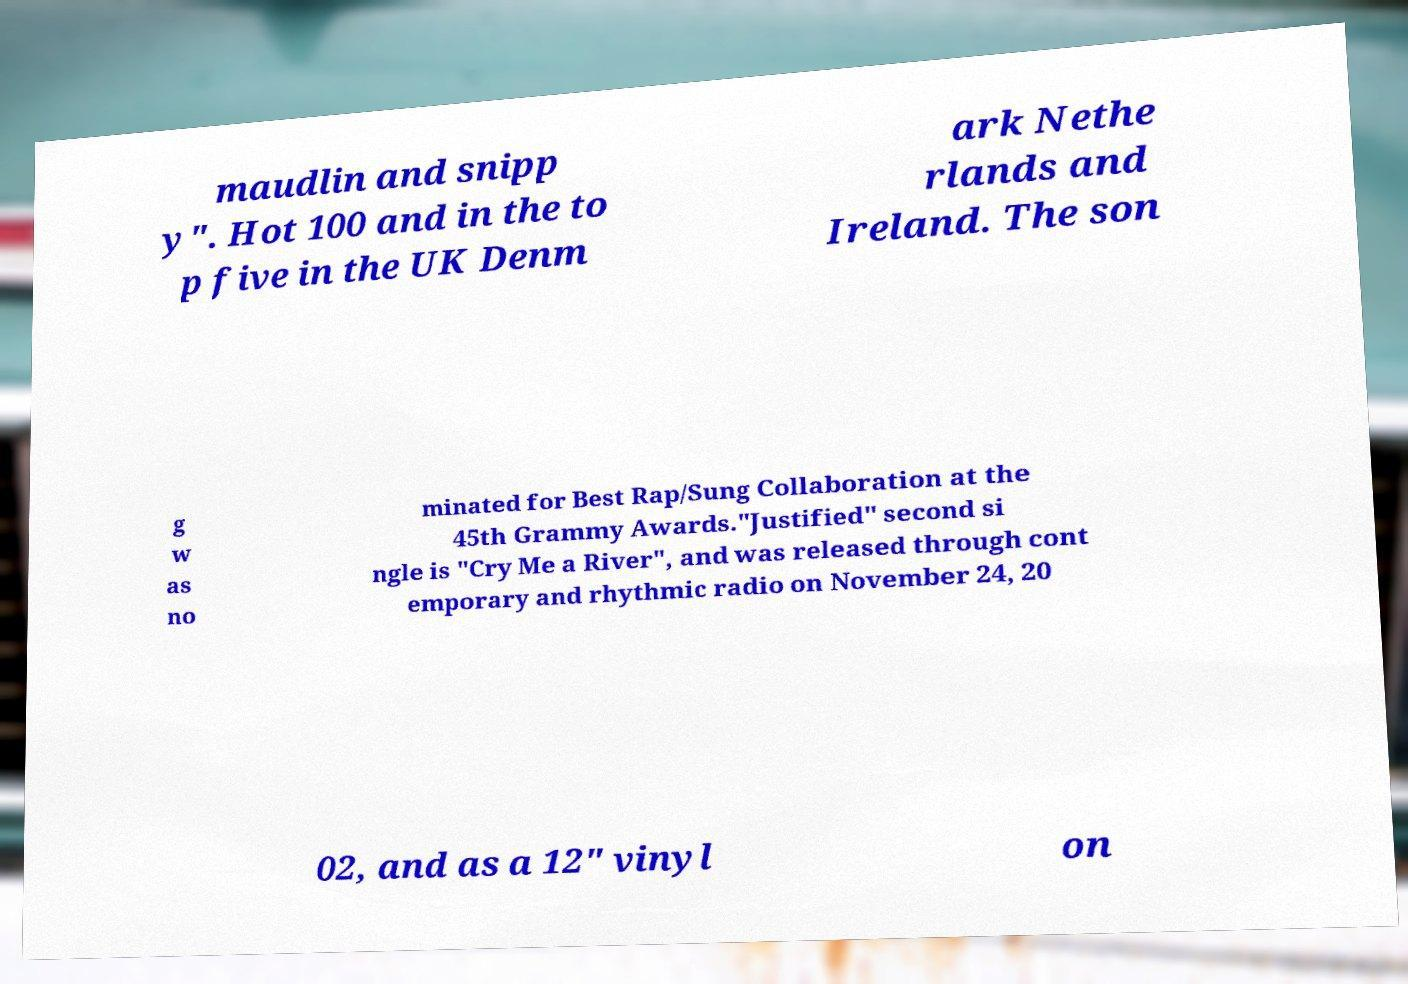What messages or text are displayed in this image? I need them in a readable, typed format. maudlin and snipp y". Hot 100 and in the to p five in the UK Denm ark Nethe rlands and Ireland. The son g w as no minated for Best Rap/Sung Collaboration at the 45th Grammy Awards."Justified" second si ngle is "Cry Me a River", and was released through cont emporary and rhythmic radio on November 24, 20 02, and as a 12" vinyl on 